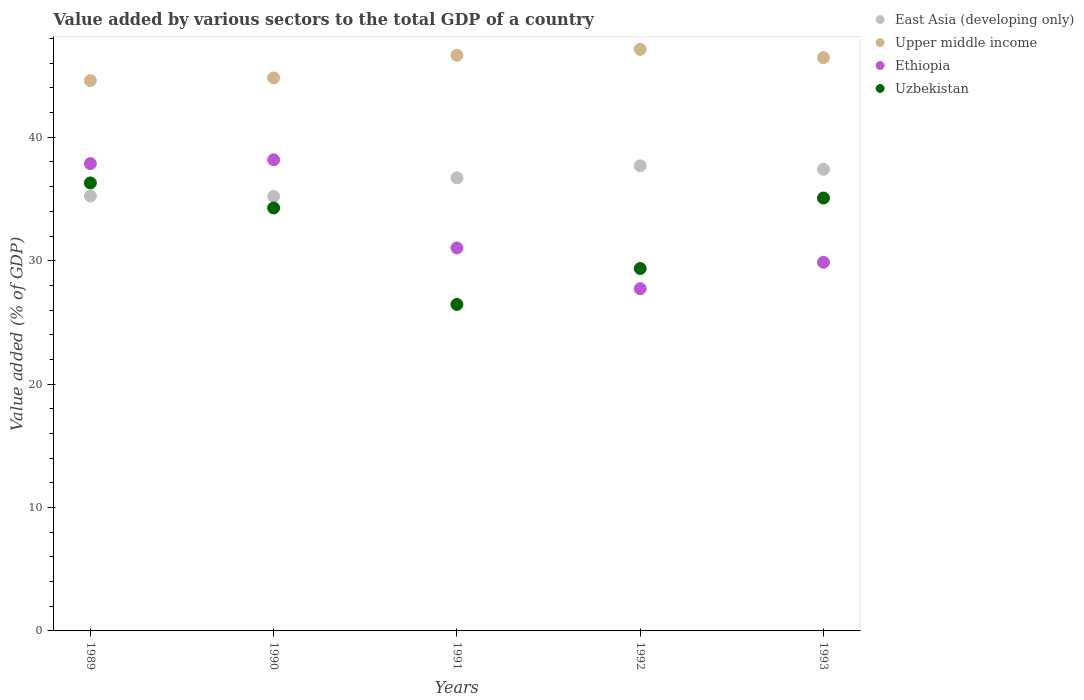Is the number of dotlines equal to the number of legend labels?
Your answer should be compact. Yes. What is the value added by various sectors to the total GDP in Ethiopia in 1989?
Give a very brief answer. 37.87. Across all years, what is the maximum value added by various sectors to the total GDP in Upper middle income?
Offer a very short reply. 47.13. Across all years, what is the minimum value added by various sectors to the total GDP in Upper middle income?
Provide a short and direct response. 44.59. In which year was the value added by various sectors to the total GDP in Upper middle income maximum?
Provide a succinct answer. 1992. In which year was the value added by various sectors to the total GDP in East Asia (developing only) minimum?
Keep it short and to the point. 1990. What is the total value added by various sectors to the total GDP in Ethiopia in the graph?
Offer a terse response. 164.68. What is the difference between the value added by various sectors to the total GDP in Ethiopia in 1992 and that in 1993?
Give a very brief answer. -2.14. What is the difference between the value added by various sectors to the total GDP in Uzbekistan in 1993 and the value added by various sectors to the total GDP in East Asia (developing only) in 1992?
Make the answer very short. -2.61. What is the average value added by various sectors to the total GDP in East Asia (developing only) per year?
Your response must be concise. 36.45. In the year 1992, what is the difference between the value added by various sectors to the total GDP in Upper middle income and value added by various sectors to the total GDP in East Asia (developing only)?
Make the answer very short. 9.44. What is the ratio of the value added by various sectors to the total GDP in Upper middle income in 1989 to that in 1993?
Your answer should be very brief. 0.96. Is the value added by various sectors to the total GDP in Ethiopia in 1989 less than that in 1991?
Give a very brief answer. No. Is the difference between the value added by various sectors to the total GDP in Upper middle income in 1991 and 1993 greater than the difference between the value added by various sectors to the total GDP in East Asia (developing only) in 1991 and 1993?
Give a very brief answer. Yes. What is the difference between the highest and the second highest value added by various sectors to the total GDP in Ethiopia?
Your response must be concise. 0.31. What is the difference between the highest and the lowest value added by various sectors to the total GDP in Upper middle income?
Provide a short and direct response. 2.53. In how many years, is the value added by various sectors to the total GDP in East Asia (developing only) greater than the average value added by various sectors to the total GDP in East Asia (developing only) taken over all years?
Your response must be concise. 3. Is it the case that in every year, the sum of the value added by various sectors to the total GDP in East Asia (developing only) and value added by various sectors to the total GDP in Ethiopia  is greater than the sum of value added by various sectors to the total GDP in Uzbekistan and value added by various sectors to the total GDP in Upper middle income?
Make the answer very short. No. Does the value added by various sectors to the total GDP in East Asia (developing only) monotonically increase over the years?
Provide a succinct answer. No. Is the value added by various sectors to the total GDP in Uzbekistan strictly greater than the value added by various sectors to the total GDP in East Asia (developing only) over the years?
Give a very brief answer. No. Are the values on the major ticks of Y-axis written in scientific E-notation?
Give a very brief answer. No. Where does the legend appear in the graph?
Your response must be concise. Top right. How many legend labels are there?
Keep it short and to the point. 4. What is the title of the graph?
Your answer should be compact. Value added by various sectors to the total GDP of a country. What is the label or title of the Y-axis?
Your response must be concise. Value added (% of GDP). What is the Value added (% of GDP) of East Asia (developing only) in 1989?
Keep it short and to the point. 35.24. What is the Value added (% of GDP) of Upper middle income in 1989?
Your answer should be very brief. 44.59. What is the Value added (% of GDP) in Ethiopia in 1989?
Provide a succinct answer. 37.87. What is the Value added (% of GDP) in Uzbekistan in 1989?
Give a very brief answer. 36.3. What is the Value added (% of GDP) in East Asia (developing only) in 1990?
Offer a terse response. 35.21. What is the Value added (% of GDP) of Upper middle income in 1990?
Offer a very short reply. 44.81. What is the Value added (% of GDP) in Ethiopia in 1990?
Make the answer very short. 38.18. What is the Value added (% of GDP) in Uzbekistan in 1990?
Your answer should be very brief. 34.27. What is the Value added (% of GDP) of East Asia (developing only) in 1991?
Offer a terse response. 36.72. What is the Value added (% of GDP) in Upper middle income in 1991?
Offer a very short reply. 46.65. What is the Value added (% of GDP) in Ethiopia in 1991?
Make the answer very short. 31.03. What is the Value added (% of GDP) of Uzbekistan in 1991?
Your response must be concise. 26.46. What is the Value added (% of GDP) of East Asia (developing only) in 1992?
Your answer should be compact. 37.69. What is the Value added (% of GDP) in Upper middle income in 1992?
Offer a very short reply. 47.13. What is the Value added (% of GDP) of Ethiopia in 1992?
Ensure brevity in your answer.  27.73. What is the Value added (% of GDP) of Uzbekistan in 1992?
Keep it short and to the point. 29.37. What is the Value added (% of GDP) of East Asia (developing only) in 1993?
Provide a short and direct response. 37.41. What is the Value added (% of GDP) of Upper middle income in 1993?
Your answer should be compact. 46.45. What is the Value added (% of GDP) in Ethiopia in 1993?
Give a very brief answer. 29.87. What is the Value added (% of GDP) of Uzbekistan in 1993?
Offer a terse response. 35.08. Across all years, what is the maximum Value added (% of GDP) of East Asia (developing only)?
Your response must be concise. 37.69. Across all years, what is the maximum Value added (% of GDP) in Upper middle income?
Your answer should be compact. 47.13. Across all years, what is the maximum Value added (% of GDP) in Ethiopia?
Ensure brevity in your answer.  38.18. Across all years, what is the maximum Value added (% of GDP) in Uzbekistan?
Keep it short and to the point. 36.3. Across all years, what is the minimum Value added (% of GDP) in East Asia (developing only)?
Make the answer very short. 35.21. Across all years, what is the minimum Value added (% of GDP) in Upper middle income?
Make the answer very short. 44.59. Across all years, what is the minimum Value added (% of GDP) of Ethiopia?
Make the answer very short. 27.73. Across all years, what is the minimum Value added (% of GDP) of Uzbekistan?
Provide a short and direct response. 26.46. What is the total Value added (% of GDP) in East Asia (developing only) in the graph?
Provide a short and direct response. 182.26. What is the total Value added (% of GDP) in Upper middle income in the graph?
Offer a very short reply. 229.63. What is the total Value added (% of GDP) of Ethiopia in the graph?
Offer a very short reply. 164.68. What is the total Value added (% of GDP) in Uzbekistan in the graph?
Offer a very short reply. 161.48. What is the difference between the Value added (% of GDP) in East Asia (developing only) in 1989 and that in 1990?
Give a very brief answer. 0.03. What is the difference between the Value added (% of GDP) of Upper middle income in 1989 and that in 1990?
Ensure brevity in your answer.  -0.22. What is the difference between the Value added (% of GDP) in Ethiopia in 1989 and that in 1990?
Ensure brevity in your answer.  -0.31. What is the difference between the Value added (% of GDP) of Uzbekistan in 1989 and that in 1990?
Provide a succinct answer. 2.03. What is the difference between the Value added (% of GDP) in East Asia (developing only) in 1989 and that in 1991?
Your answer should be compact. -1.48. What is the difference between the Value added (% of GDP) of Upper middle income in 1989 and that in 1991?
Your answer should be very brief. -2.05. What is the difference between the Value added (% of GDP) of Ethiopia in 1989 and that in 1991?
Ensure brevity in your answer.  6.83. What is the difference between the Value added (% of GDP) of Uzbekistan in 1989 and that in 1991?
Keep it short and to the point. 9.85. What is the difference between the Value added (% of GDP) in East Asia (developing only) in 1989 and that in 1992?
Offer a very short reply. -2.45. What is the difference between the Value added (% of GDP) in Upper middle income in 1989 and that in 1992?
Ensure brevity in your answer.  -2.53. What is the difference between the Value added (% of GDP) of Ethiopia in 1989 and that in 1992?
Your answer should be compact. 10.14. What is the difference between the Value added (% of GDP) in Uzbekistan in 1989 and that in 1992?
Your response must be concise. 6.94. What is the difference between the Value added (% of GDP) in East Asia (developing only) in 1989 and that in 1993?
Your answer should be compact. -2.17. What is the difference between the Value added (% of GDP) in Upper middle income in 1989 and that in 1993?
Your answer should be very brief. -1.86. What is the difference between the Value added (% of GDP) in Ethiopia in 1989 and that in 1993?
Offer a very short reply. 8. What is the difference between the Value added (% of GDP) of Uzbekistan in 1989 and that in 1993?
Your answer should be compact. 1.22. What is the difference between the Value added (% of GDP) in East Asia (developing only) in 1990 and that in 1991?
Offer a terse response. -1.51. What is the difference between the Value added (% of GDP) in Upper middle income in 1990 and that in 1991?
Provide a short and direct response. -1.83. What is the difference between the Value added (% of GDP) of Ethiopia in 1990 and that in 1991?
Your response must be concise. 7.14. What is the difference between the Value added (% of GDP) in Uzbekistan in 1990 and that in 1991?
Offer a very short reply. 7.82. What is the difference between the Value added (% of GDP) of East Asia (developing only) in 1990 and that in 1992?
Ensure brevity in your answer.  -2.48. What is the difference between the Value added (% of GDP) in Upper middle income in 1990 and that in 1992?
Make the answer very short. -2.31. What is the difference between the Value added (% of GDP) of Ethiopia in 1990 and that in 1992?
Your answer should be compact. 10.45. What is the difference between the Value added (% of GDP) in Uzbekistan in 1990 and that in 1992?
Your answer should be compact. 4.91. What is the difference between the Value added (% of GDP) in East Asia (developing only) in 1990 and that in 1993?
Provide a short and direct response. -2.2. What is the difference between the Value added (% of GDP) of Upper middle income in 1990 and that in 1993?
Make the answer very short. -1.64. What is the difference between the Value added (% of GDP) in Ethiopia in 1990 and that in 1993?
Your answer should be very brief. 8.31. What is the difference between the Value added (% of GDP) in Uzbekistan in 1990 and that in 1993?
Your response must be concise. -0.81. What is the difference between the Value added (% of GDP) of East Asia (developing only) in 1991 and that in 1992?
Your response must be concise. -0.97. What is the difference between the Value added (% of GDP) of Upper middle income in 1991 and that in 1992?
Offer a terse response. -0.48. What is the difference between the Value added (% of GDP) in Ethiopia in 1991 and that in 1992?
Ensure brevity in your answer.  3.3. What is the difference between the Value added (% of GDP) of Uzbekistan in 1991 and that in 1992?
Offer a terse response. -2.91. What is the difference between the Value added (% of GDP) of East Asia (developing only) in 1991 and that in 1993?
Make the answer very short. -0.69. What is the difference between the Value added (% of GDP) in Upper middle income in 1991 and that in 1993?
Provide a succinct answer. 0.19. What is the difference between the Value added (% of GDP) in Ethiopia in 1991 and that in 1993?
Offer a terse response. 1.16. What is the difference between the Value added (% of GDP) in Uzbekistan in 1991 and that in 1993?
Offer a very short reply. -8.62. What is the difference between the Value added (% of GDP) in East Asia (developing only) in 1992 and that in 1993?
Give a very brief answer. 0.28. What is the difference between the Value added (% of GDP) in Upper middle income in 1992 and that in 1993?
Make the answer very short. 0.67. What is the difference between the Value added (% of GDP) of Ethiopia in 1992 and that in 1993?
Make the answer very short. -2.14. What is the difference between the Value added (% of GDP) of Uzbekistan in 1992 and that in 1993?
Provide a succinct answer. -5.71. What is the difference between the Value added (% of GDP) of East Asia (developing only) in 1989 and the Value added (% of GDP) of Upper middle income in 1990?
Keep it short and to the point. -9.57. What is the difference between the Value added (% of GDP) in East Asia (developing only) in 1989 and the Value added (% of GDP) in Ethiopia in 1990?
Keep it short and to the point. -2.94. What is the difference between the Value added (% of GDP) of East Asia (developing only) in 1989 and the Value added (% of GDP) of Uzbekistan in 1990?
Provide a short and direct response. 0.97. What is the difference between the Value added (% of GDP) in Upper middle income in 1989 and the Value added (% of GDP) in Ethiopia in 1990?
Keep it short and to the point. 6.42. What is the difference between the Value added (% of GDP) of Upper middle income in 1989 and the Value added (% of GDP) of Uzbekistan in 1990?
Offer a very short reply. 10.32. What is the difference between the Value added (% of GDP) of Ethiopia in 1989 and the Value added (% of GDP) of Uzbekistan in 1990?
Offer a very short reply. 3.6. What is the difference between the Value added (% of GDP) of East Asia (developing only) in 1989 and the Value added (% of GDP) of Upper middle income in 1991?
Keep it short and to the point. -11.41. What is the difference between the Value added (% of GDP) in East Asia (developing only) in 1989 and the Value added (% of GDP) in Ethiopia in 1991?
Provide a short and direct response. 4.21. What is the difference between the Value added (% of GDP) in East Asia (developing only) in 1989 and the Value added (% of GDP) in Uzbekistan in 1991?
Keep it short and to the point. 8.78. What is the difference between the Value added (% of GDP) of Upper middle income in 1989 and the Value added (% of GDP) of Ethiopia in 1991?
Your answer should be very brief. 13.56. What is the difference between the Value added (% of GDP) in Upper middle income in 1989 and the Value added (% of GDP) in Uzbekistan in 1991?
Provide a succinct answer. 18.14. What is the difference between the Value added (% of GDP) in Ethiopia in 1989 and the Value added (% of GDP) in Uzbekistan in 1991?
Your answer should be compact. 11.41. What is the difference between the Value added (% of GDP) in East Asia (developing only) in 1989 and the Value added (% of GDP) in Upper middle income in 1992?
Give a very brief answer. -11.89. What is the difference between the Value added (% of GDP) in East Asia (developing only) in 1989 and the Value added (% of GDP) in Ethiopia in 1992?
Provide a short and direct response. 7.51. What is the difference between the Value added (% of GDP) in East Asia (developing only) in 1989 and the Value added (% of GDP) in Uzbekistan in 1992?
Offer a terse response. 5.87. What is the difference between the Value added (% of GDP) in Upper middle income in 1989 and the Value added (% of GDP) in Ethiopia in 1992?
Your response must be concise. 16.87. What is the difference between the Value added (% of GDP) in Upper middle income in 1989 and the Value added (% of GDP) in Uzbekistan in 1992?
Ensure brevity in your answer.  15.23. What is the difference between the Value added (% of GDP) in Ethiopia in 1989 and the Value added (% of GDP) in Uzbekistan in 1992?
Keep it short and to the point. 8.5. What is the difference between the Value added (% of GDP) of East Asia (developing only) in 1989 and the Value added (% of GDP) of Upper middle income in 1993?
Your response must be concise. -11.21. What is the difference between the Value added (% of GDP) of East Asia (developing only) in 1989 and the Value added (% of GDP) of Ethiopia in 1993?
Offer a very short reply. 5.37. What is the difference between the Value added (% of GDP) of East Asia (developing only) in 1989 and the Value added (% of GDP) of Uzbekistan in 1993?
Give a very brief answer. 0.16. What is the difference between the Value added (% of GDP) in Upper middle income in 1989 and the Value added (% of GDP) in Ethiopia in 1993?
Give a very brief answer. 14.72. What is the difference between the Value added (% of GDP) of Upper middle income in 1989 and the Value added (% of GDP) of Uzbekistan in 1993?
Make the answer very short. 9.52. What is the difference between the Value added (% of GDP) in Ethiopia in 1989 and the Value added (% of GDP) in Uzbekistan in 1993?
Give a very brief answer. 2.79. What is the difference between the Value added (% of GDP) in East Asia (developing only) in 1990 and the Value added (% of GDP) in Upper middle income in 1991?
Offer a terse response. -11.44. What is the difference between the Value added (% of GDP) of East Asia (developing only) in 1990 and the Value added (% of GDP) of Ethiopia in 1991?
Make the answer very short. 4.17. What is the difference between the Value added (% of GDP) of East Asia (developing only) in 1990 and the Value added (% of GDP) of Uzbekistan in 1991?
Your answer should be very brief. 8.75. What is the difference between the Value added (% of GDP) of Upper middle income in 1990 and the Value added (% of GDP) of Ethiopia in 1991?
Your answer should be compact. 13.78. What is the difference between the Value added (% of GDP) of Upper middle income in 1990 and the Value added (% of GDP) of Uzbekistan in 1991?
Give a very brief answer. 18.36. What is the difference between the Value added (% of GDP) in Ethiopia in 1990 and the Value added (% of GDP) in Uzbekistan in 1991?
Make the answer very short. 11.72. What is the difference between the Value added (% of GDP) in East Asia (developing only) in 1990 and the Value added (% of GDP) in Upper middle income in 1992?
Your answer should be compact. -11.92. What is the difference between the Value added (% of GDP) in East Asia (developing only) in 1990 and the Value added (% of GDP) in Ethiopia in 1992?
Provide a succinct answer. 7.48. What is the difference between the Value added (% of GDP) in East Asia (developing only) in 1990 and the Value added (% of GDP) in Uzbekistan in 1992?
Keep it short and to the point. 5.84. What is the difference between the Value added (% of GDP) in Upper middle income in 1990 and the Value added (% of GDP) in Ethiopia in 1992?
Your answer should be compact. 17.08. What is the difference between the Value added (% of GDP) in Upper middle income in 1990 and the Value added (% of GDP) in Uzbekistan in 1992?
Give a very brief answer. 15.45. What is the difference between the Value added (% of GDP) of Ethiopia in 1990 and the Value added (% of GDP) of Uzbekistan in 1992?
Provide a short and direct response. 8.81. What is the difference between the Value added (% of GDP) in East Asia (developing only) in 1990 and the Value added (% of GDP) in Upper middle income in 1993?
Offer a terse response. -11.25. What is the difference between the Value added (% of GDP) in East Asia (developing only) in 1990 and the Value added (% of GDP) in Ethiopia in 1993?
Keep it short and to the point. 5.34. What is the difference between the Value added (% of GDP) in East Asia (developing only) in 1990 and the Value added (% of GDP) in Uzbekistan in 1993?
Provide a succinct answer. 0.13. What is the difference between the Value added (% of GDP) in Upper middle income in 1990 and the Value added (% of GDP) in Ethiopia in 1993?
Make the answer very short. 14.94. What is the difference between the Value added (% of GDP) of Upper middle income in 1990 and the Value added (% of GDP) of Uzbekistan in 1993?
Your response must be concise. 9.73. What is the difference between the Value added (% of GDP) in Ethiopia in 1990 and the Value added (% of GDP) in Uzbekistan in 1993?
Provide a short and direct response. 3.1. What is the difference between the Value added (% of GDP) of East Asia (developing only) in 1991 and the Value added (% of GDP) of Upper middle income in 1992?
Provide a succinct answer. -10.41. What is the difference between the Value added (% of GDP) of East Asia (developing only) in 1991 and the Value added (% of GDP) of Ethiopia in 1992?
Ensure brevity in your answer.  8.99. What is the difference between the Value added (% of GDP) in East Asia (developing only) in 1991 and the Value added (% of GDP) in Uzbekistan in 1992?
Your answer should be very brief. 7.35. What is the difference between the Value added (% of GDP) in Upper middle income in 1991 and the Value added (% of GDP) in Ethiopia in 1992?
Provide a short and direct response. 18.92. What is the difference between the Value added (% of GDP) in Upper middle income in 1991 and the Value added (% of GDP) in Uzbekistan in 1992?
Provide a short and direct response. 17.28. What is the difference between the Value added (% of GDP) in Ethiopia in 1991 and the Value added (% of GDP) in Uzbekistan in 1992?
Your answer should be compact. 1.67. What is the difference between the Value added (% of GDP) of East Asia (developing only) in 1991 and the Value added (% of GDP) of Upper middle income in 1993?
Provide a succinct answer. -9.74. What is the difference between the Value added (% of GDP) in East Asia (developing only) in 1991 and the Value added (% of GDP) in Ethiopia in 1993?
Provide a succinct answer. 6.85. What is the difference between the Value added (% of GDP) in East Asia (developing only) in 1991 and the Value added (% of GDP) in Uzbekistan in 1993?
Provide a short and direct response. 1.64. What is the difference between the Value added (% of GDP) of Upper middle income in 1991 and the Value added (% of GDP) of Ethiopia in 1993?
Make the answer very short. 16.78. What is the difference between the Value added (% of GDP) in Upper middle income in 1991 and the Value added (% of GDP) in Uzbekistan in 1993?
Provide a short and direct response. 11.57. What is the difference between the Value added (% of GDP) in Ethiopia in 1991 and the Value added (% of GDP) in Uzbekistan in 1993?
Provide a succinct answer. -4.05. What is the difference between the Value added (% of GDP) of East Asia (developing only) in 1992 and the Value added (% of GDP) of Upper middle income in 1993?
Give a very brief answer. -8.77. What is the difference between the Value added (% of GDP) in East Asia (developing only) in 1992 and the Value added (% of GDP) in Ethiopia in 1993?
Keep it short and to the point. 7.81. What is the difference between the Value added (% of GDP) in East Asia (developing only) in 1992 and the Value added (% of GDP) in Uzbekistan in 1993?
Provide a succinct answer. 2.61. What is the difference between the Value added (% of GDP) in Upper middle income in 1992 and the Value added (% of GDP) in Ethiopia in 1993?
Make the answer very short. 17.26. What is the difference between the Value added (% of GDP) in Upper middle income in 1992 and the Value added (% of GDP) in Uzbekistan in 1993?
Your response must be concise. 12.05. What is the difference between the Value added (% of GDP) in Ethiopia in 1992 and the Value added (% of GDP) in Uzbekistan in 1993?
Provide a succinct answer. -7.35. What is the average Value added (% of GDP) in East Asia (developing only) per year?
Keep it short and to the point. 36.45. What is the average Value added (% of GDP) of Upper middle income per year?
Provide a succinct answer. 45.93. What is the average Value added (% of GDP) of Ethiopia per year?
Your answer should be very brief. 32.94. What is the average Value added (% of GDP) in Uzbekistan per year?
Your answer should be very brief. 32.3. In the year 1989, what is the difference between the Value added (% of GDP) in East Asia (developing only) and Value added (% of GDP) in Upper middle income?
Make the answer very short. -9.35. In the year 1989, what is the difference between the Value added (% of GDP) of East Asia (developing only) and Value added (% of GDP) of Ethiopia?
Offer a terse response. -2.63. In the year 1989, what is the difference between the Value added (% of GDP) of East Asia (developing only) and Value added (% of GDP) of Uzbekistan?
Offer a terse response. -1.06. In the year 1989, what is the difference between the Value added (% of GDP) in Upper middle income and Value added (% of GDP) in Ethiopia?
Provide a short and direct response. 6.73. In the year 1989, what is the difference between the Value added (% of GDP) of Upper middle income and Value added (% of GDP) of Uzbekistan?
Your answer should be very brief. 8.29. In the year 1989, what is the difference between the Value added (% of GDP) in Ethiopia and Value added (% of GDP) in Uzbekistan?
Your answer should be compact. 1.57. In the year 1990, what is the difference between the Value added (% of GDP) in East Asia (developing only) and Value added (% of GDP) in Upper middle income?
Offer a very short reply. -9.6. In the year 1990, what is the difference between the Value added (% of GDP) of East Asia (developing only) and Value added (% of GDP) of Ethiopia?
Make the answer very short. -2.97. In the year 1990, what is the difference between the Value added (% of GDP) in East Asia (developing only) and Value added (% of GDP) in Uzbekistan?
Provide a succinct answer. 0.94. In the year 1990, what is the difference between the Value added (% of GDP) in Upper middle income and Value added (% of GDP) in Ethiopia?
Give a very brief answer. 6.64. In the year 1990, what is the difference between the Value added (% of GDP) in Upper middle income and Value added (% of GDP) in Uzbekistan?
Provide a short and direct response. 10.54. In the year 1990, what is the difference between the Value added (% of GDP) in Ethiopia and Value added (% of GDP) in Uzbekistan?
Offer a very short reply. 3.9. In the year 1991, what is the difference between the Value added (% of GDP) in East Asia (developing only) and Value added (% of GDP) in Upper middle income?
Your response must be concise. -9.93. In the year 1991, what is the difference between the Value added (% of GDP) of East Asia (developing only) and Value added (% of GDP) of Ethiopia?
Offer a terse response. 5.68. In the year 1991, what is the difference between the Value added (% of GDP) of East Asia (developing only) and Value added (% of GDP) of Uzbekistan?
Provide a succinct answer. 10.26. In the year 1991, what is the difference between the Value added (% of GDP) in Upper middle income and Value added (% of GDP) in Ethiopia?
Keep it short and to the point. 15.61. In the year 1991, what is the difference between the Value added (% of GDP) in Upper middle income and Value added (% of GDP) in Uzbekistan?
Provide a short and direct response. 20.19. In the year 1991, what is the difference between the Value added (% of GDP) of Ethiopia and Value added (% of GDP) of Uzbekistan?
Your answer should be compact. 4.58. In the year 1992, what is the difference between the Value added (% of GDP) of East Asia (developing only) and Value added (% of GDP) of Upper middle income?
Provide a succinct answer. -9.44. In the year 1992, what is the difference between the Value added (% of GDP) of East Asia (developing only) and Value added (% of GDP) of Ethiopia?
Your answer should be very brief. 9.96. In the year 1992, what is the difference between the Value added (% of GDP) in East Asia (developing only) and Value added (% of GDP) in Uzbekistan?
Keep it short and to the point. 8.32. In the year 1992, what is the difference between the Value added (% of GDP) of Upper middle income and Value added (% of GDP) of Ethiopia?
Make the answer very short. 19.4. In the year 1992, what is the difference between the Value added (% of GDP) in Upper middle income and Value added (% of GDP) in Uzbekistan?
Offer a terse response. 17.76. In the year 1992, what is the difference between the Value added (% of GDP) in Ethiopia and Value added (% of GDP) in Uzbekistan?
Your answer should be very brief. -1.64. In the year 1993, what is the difference between the Value added (% of GDP) of East Asia (developing only) and Value added (% of GDP) of Upper middle income?
Give a very brief answer. -9.05. In the year 1993, what is the difference between the Value added (% of GDP) in East Asia (developing only) and Value added (% of GDP) in Ethiopia?
Provide a succinct answer. 7.54. In the year 1993, what is the difference between the Value added (% of GDP) of East Asia (developing only) and Value added (% of GDP) of Uzbekistan?
Ensure brevity in your answer.  2.33. In the year 1993, what is the difference between the Value added (% of GDP) of Upper middle income and Value added (% of GDP) of Ethiopia?
Your response must be concise. 16.58. In the year 1993, what is the difference between the Value added (% of GDP) in Upper middle income and Value added (% of GDP) in Uzbekistan?
Your answer should be compact. 11.38. In the year 1993, what is the difference between the Value added (% of GDP) in Ethiopia and Value added (% of GDP) in Uzbekistan?
Offer a terse response. -5.21. What is the ratio of the Value added (% of GDP) of East Asia (developing only) in 1989 to that in 1990?
Your answer should be compact. 1. What is the ratio of the Value added (% of GDP) in Ethiopia in 1989 to that in 1990?
Keep it short and to the point. 0.99. What is the ratio of the Value added (% of GDP) in Uzbekistan in 1989 to that in 1990?
Make the answer very short. 1.06. What is the ratio of the Value added (% of GDP) in East Asia (developing only) in 1989 to that in 1991?
Provide a short and direct response. 0.96. What is the ratio of the Value added (% of GDP) of Upper middle income in 1989 to that in 1991?
Keep it short and to the point. 0.96. What is the ratio of the Value added (% of GDP) of Ethiopia in 1989 to that in 1991?
Provide a short and direct response. 1.22. What is the ratio of the Value added (% of GDP) in Uzbekistan in 1989 to that in 1991?
Your response must be concise. 1.37. What is the ratio of the Value added (% of GDP) of East Asia (developing only) in 1989 to that in 1992?
Your response must be concise. 0.94. What is the ratio of the Value added (% of GDP) in Upper middle income in 1989 to that in 1992?
Offer a very short reply. 0.95. What is the ratio of the Value added (% of GDP) in Ethiopia in 1989 to that in 1992?
Make the answer very short. 1.37. What is the ratio of the Value added (% of GDP) of Uzbekistan in 1989 to that in 1992?
Offer a very short reply. 1.24. What is the ratio of the Value added (% of GDP) in East Asia (developing only) in 1989 to that in 1993?
Your answer should be very brief. 0.94. What is the ratio of the Value added (% of GDP) of Upper middle income in 1989 to that in 1993?
Provide a short and direct response. 0.96. What is the ratio of the Value added (% of GDP) in Ethiopia in 1989 to that in 1993?
Keep it short and to the point. 1.27. What is the ratio of the Value added (% of GDP) of Uzbekistan in 1989 to that in 1993?
Make the answer very short. 1.03. What is the ratio of the Value added (% of GDP) in East Asia (developing only) in 1990 to that in 1991?
Offer a very short reply. 0.96. What is the ratio of the Value added (% of GDP) in Upper middle income in 1990 to that in 1991?
Your answer should be very brief. 0.96. What is the ratio of the Value added (% of GDP) of Ethiopia in 1990 to that in 1991?
Keep it short and to the point. 1.23. What is the ratio of the Value added (% of GDP) of Uzbekistan in 1990 to that in 1991?
Offer a very short reply. 1.3. What is the ratio of the Value added (% of GDP) of East Asia (developing only) in 1990 to that in 1992?
Give a very brief answer. 0.93. What is the ratio of the Value added (% of GDP) of Upper middle income in 1990 to that in 1992?
Provide a succinct answer. 0.95. What is the ratio of the Value added (% of GDP) in Ethiopia in 1990 to that in 1992?
Provide a short and direct response. 1.38. What is the ratio of the Value added (% of GDP) of Uzbekistan in 1990 to that in 1992?
Offer a terse response. 1.17. What is the ratio of the Value added (% of GDP) of Upper middle income in 1990 to that in 1993?
Make the answer very short. 0.96. What is the ratio of the Value added (% of GDP) in Ethiopia in 1990 to that in 1993?
Your answer should be compact. 1.28. What is the ratio of the Value added (% of GDP) of Uzbekistan in 1990 to that in 1993?
Your answer should be compact. 0.98. What is the ratio of the Value added (% of GDP) in East Asia (developing only) in 1991 to that in 1992?
Offer a very short reply. 0.97. What is the ratio of the Value added (% of GDP) in Ethiopia in 1991 to that in 1992?
Provide a short and direct response. 1.12. What is the ratio of the Value added (% of GDP) in Uzbekistan in 1991 to that in 1992?
Offer a very short reply. 0.9. What is the ratio of the Value added (% of GDP) in East Asia (developing only) in 1991 to that in 1993?
Offer a terse response. 0.98. What is the ratio of the Value added (% of GDP) in Upper middle income in 1991 to that in 1993?
Your answer should be compact. 1. What is the ratio of the Value added (% of GDP) of Ethiopia in 1991 to that in 1993?
Provide a short and direct response. 1.04. What is the ratio of the Value added (% of GDP) in Uzbekistan in 1991 to that in 1993?
Offer a terse response. 0.75. What is the ratio of the Value added (% of GDP) of East Asia (developing only) in 1992 to that in 1993?
Ensure brevity in your answer.  1.01. What is the ratio of the Value added (% of GDP) in Upper middle income in 1992 to that in 1993?
Provide a short and direct response. 1.01. What is the ratio of the Value added (% of GDP) of Ethiopia in 1992 to that in 1993?
Your response must be concise. 0.93. What is the ratio of the Value added (% of GDP) of Uzbekistan in 1992 to that in 1993?
Offer a very short reply. 0.84. What is the difference between the highest and the second highest Value added (% of GDP) of East Asia (developing only)?
Provide a succinct answer. 0.28. What is the difference between the highest and the second highest Value added (% of GDP) in Upper middle income?
Provide a short and direct response. 0.48. What is the difference between the highest and the second highest Value added (% of GDP) in Ethiopia?
Offer a very short reply. 0.31. What is the difference between the highest and the second highest Value added (% of GDP) of Uzbekistan?
Provide a short and direct response. 1.22. What is the difference between the highest and the lowest Value added (% of GDP) of East Asia (developing only)?
Your answer should be compact. 2.48. What is the difference between the highest and the lowest Value added (% of GDP) of Upper middle income?
Provide a short and direct response. 2.53. What is the difference between the highest and the lowest Value added (% of GDP) in Ethiopia?
Offer a very short reply. 10.45. What is the difference between the highest and the lowest Value added (% of GDP) in Uzbekistan?
Provide a short and direct response. 9.85. 